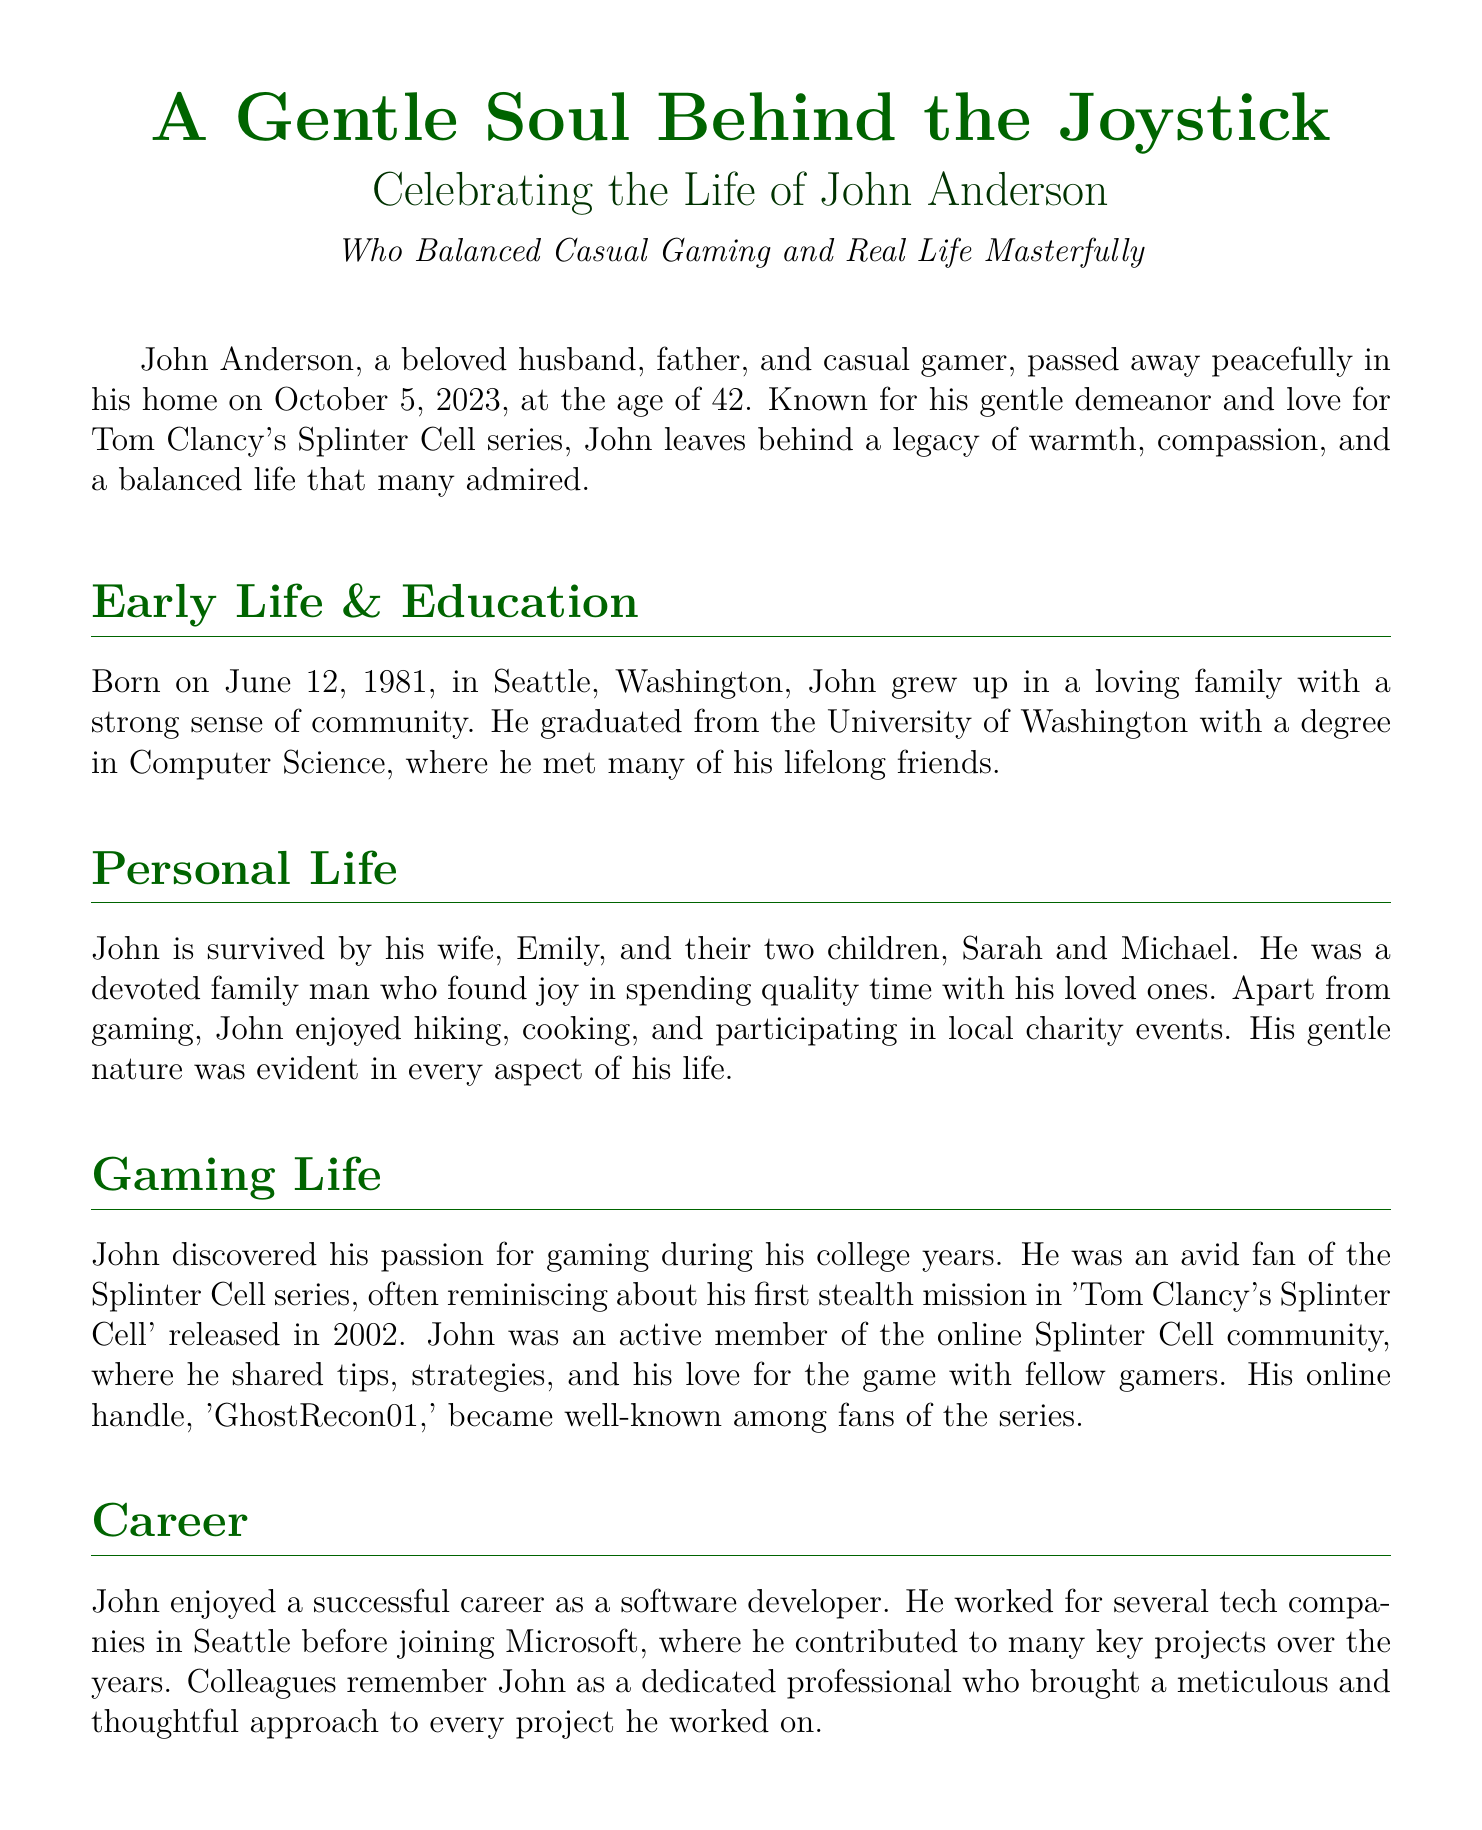What was John Anderson's age at the time of his passing? The document states that John Anderson passed away at the age of 42.
Answer: 42 What series of games was John particularly fond of? The document mentions that John loved Tom Clancy's Splinter Cell series.
Answer: Splinter Cell When was John Anderson born? The document indicates that John was born on June 12, 1981.
Answer: June 12, 1981 Where was the memorial service held? The document specifies that the memorial service will be held at Greenlake Community Church in Seattle, Washington.
Answer: Greenlake Community Church, Seattle, Washington What was John’s online handle? The document reveals that John’s online handle in the gaming community was 'GhostRecon01'.
Answer: GhostRecon01 What degree did John earn from the University of Washington? The document states that John graduated with a degree in Computer Science.
Answer: Computer Science How many children did John leave behind? The document mentions that John is survived by two children.
Answer: Two What type of activities did John enjoy aside from gaming? The document lists hiking, cooking, and participating in local charity events as activities John enjoyed.
Answer: Hiking, cooking, charity events What was one of John’s key traits observed by his colleagues? The document highlights that colleagues remembered John as a dedicated professional who brought a meticulous and thoughtful approach.
Answer: Meticulous and thoughtful 